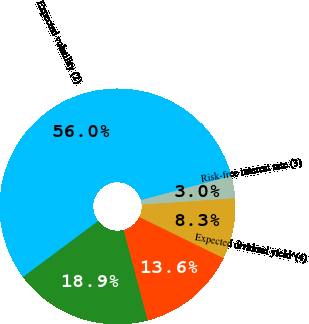<chart> <loc_0><loc_0><loc_500><loc_500><pie_chart><fcel>Weighted-average fair value<fcel>Expected volatility (2)<fcel>Risk-free interest rate (3)<fcel>Expected dividend yield^(4)<fcel>Expected term in years (5)<nl><fcel>18.94%<fcel>56.03%<fcel>3.05%<fcel>8.34%<fcel>13.64%<nl></chart> 